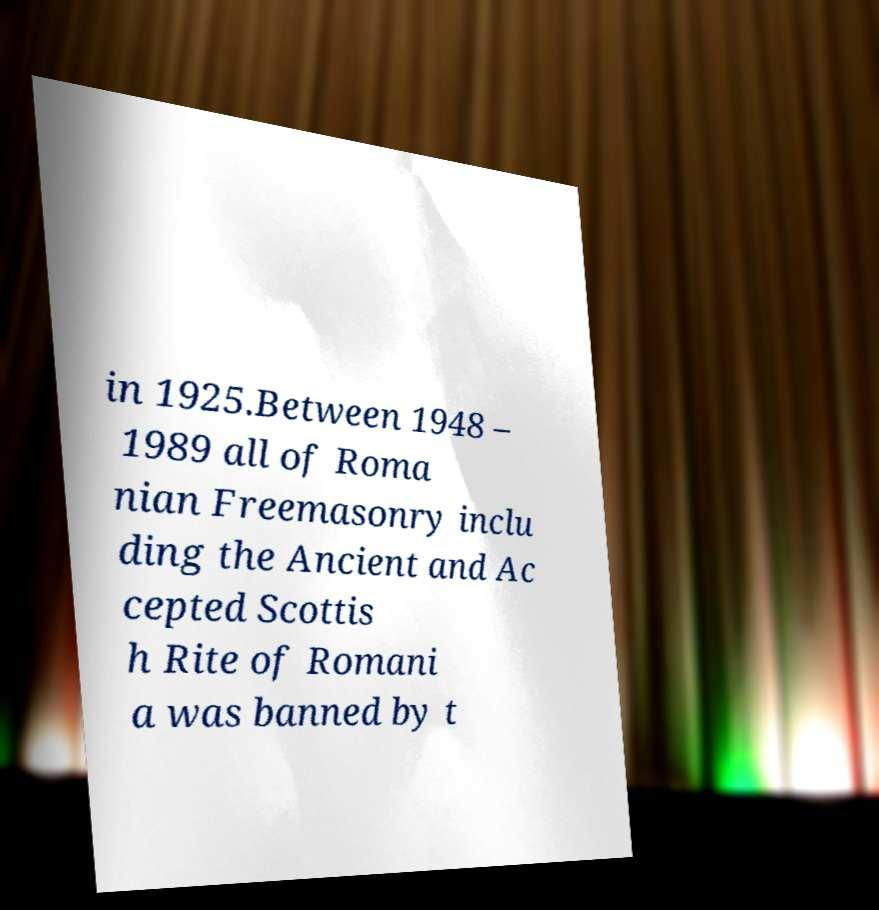Could you assist in decoding the text presented in this image and type it out clearly? in 1925.Between 1948 – 1989 all of Roma nian Freemasonry inclu ding the Ancient and Ac cepted Scottis h Rite of Romani a was banned by t 